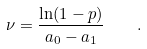Convert formula to latex. <formula><loc_0><loc_0><loc_500><loc_500>\nu = \frac { \ln ( 1 - p ) } { a _ { 0 } - a _ { 1 } } \quad .</formula> 